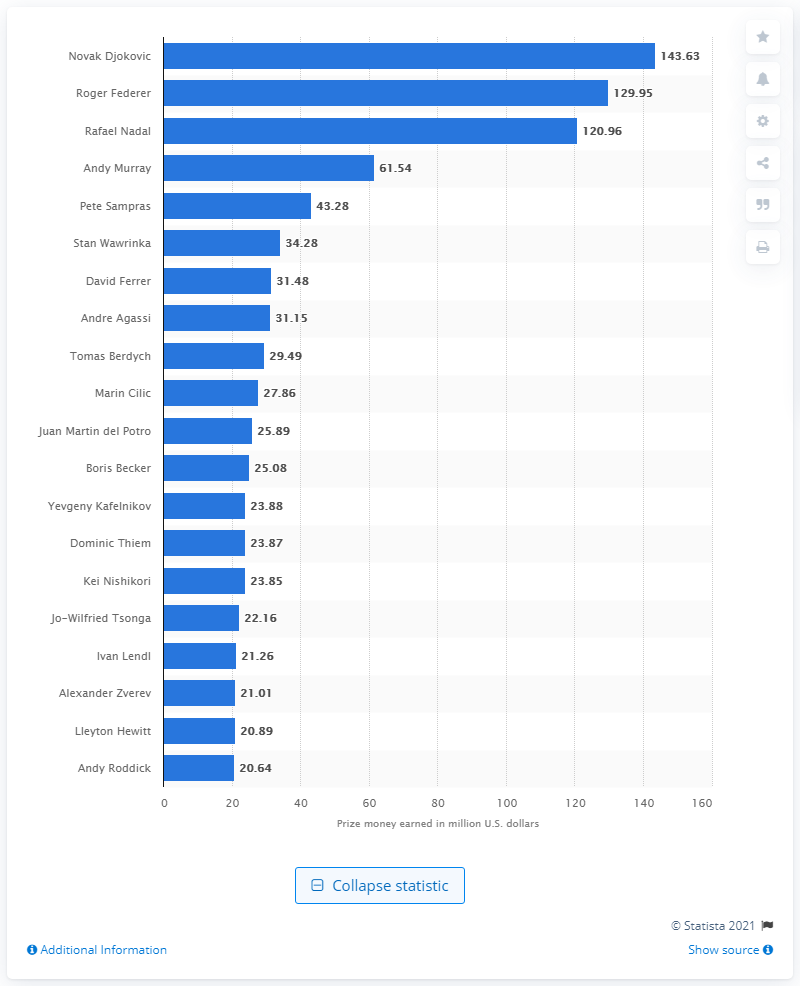Specify some key components in this picture. Novak Djokovic is the career leader in prize money earnings on the ATP tennis World Tour. Novak Djokovic earns a significant amount of money on the ATP tennis World Tour, with a current total of 143.63... 